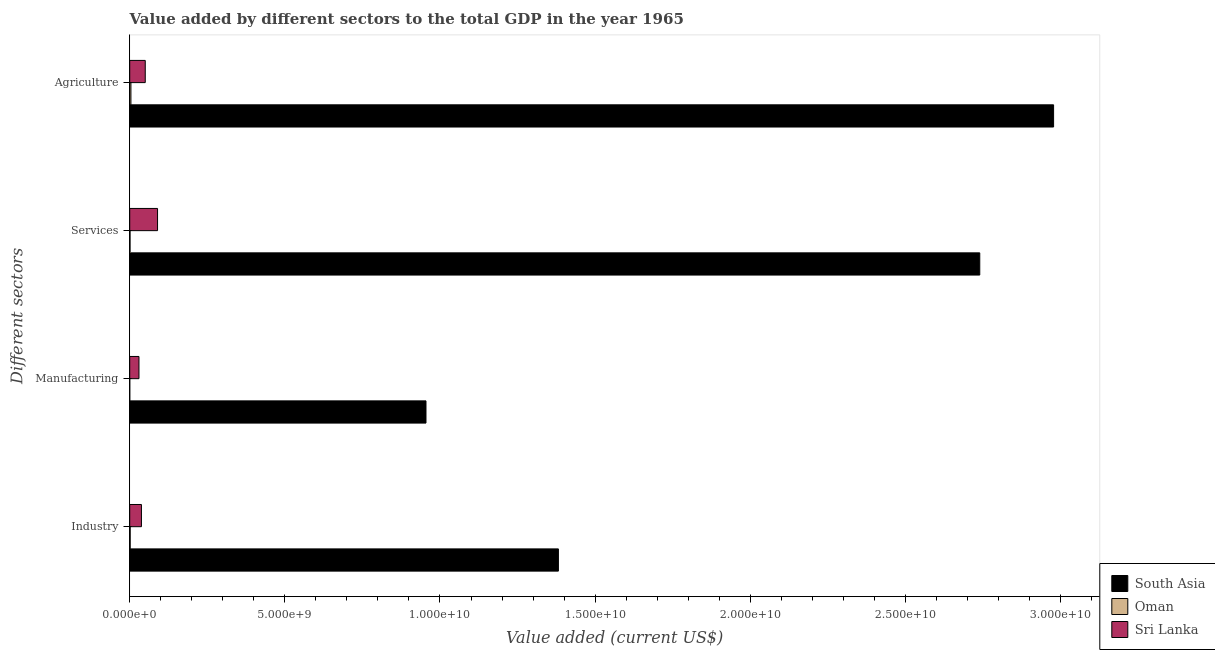How many different coloured bars are there?
Make the answer very short. 3. How many groups of bars are there?
Your answer should be very brief. 4. Are the number of bars per tick equal to the number of legend labels?
Ensure brevity in your answer.  Yes. Are the number of bars on each tick of the Y-axis equal?
Keep it short and to the point. Yes. How many bars are there on the 4th tick from the top?
Provide a succinct answer. 3. How many bars are there on the 2nd tick from the bottom?
Your answer should be compact. 3. What is the label of the 3rd group of bars from the top?
Offer a very short reply. Manufacturing. What is the value added by industrial sector in South Asia?
Provide a succinct answer. 1.38e+1. Across all countries, what is the maximum value added by services sector?
Offer a very short reply. 2.74e+1. Across all countries, what is the minimum value added by industrial sector?
Your answer should be very brief. 1.48e+07. In which country was the value added by agricultural sector minimum?
Your response must be concise. Oman. What is the total value added by industrial sector in the graph?
Ensure brevity in your answer.  1.42e+1. What is the difference between the value added by services sector in Oman and that in Sri Lanka?
Keep it short and to the point. -8.87e+08. What is the difference between the value added by industrial sector in Oman and the value added by services sector in Sri Lanka?
Ensure brevity in your answer.  -8.82e+08. What is the average value added by services sector per country?
Give a very brief answer. 9.44e+09. What is the difference between the value added by agricultural sector and value added by industrial sector in Sri Lanka?
Offer a very short reply. 1.23e+08. In how many countries, is the value added by agricultural sector greater than 17000000000 US$?
Give a very brief answer. 1. What is the ratio of the value added by agricultural sector in Oman to that in Sri Lanka?
Ensure brevity in your answer.  0.08. Is the value added by industrial sector in South Asia less than that in Sri Lanka?
Provide a short and direct response. No. Is the difference between the value added by industrial sector in Oman and Sri Lanka greater than the difference between the value added by services sector in Oman and Sri Lanka?
Give a very brief answer. Yes. What is the difference between the highest and the second highest value added by industrial sector?
Keep it short and to the point. 1.34e+1. What is the difference between the highest and the lowest value added by services sector?
Give a very brief answer. 2.74e+1. Is the sum of the value added by industrial sector in Oman and Sri Lanka greater than the maximum value added by services sector across all countries?
Keep it short and to the point. No. Is it the case that in every country, the sum of the value added by manufacturing sector and value added by industrial sector is greater than the sum of value added by services sector and value added by agricultural sector?
Provide a short and direct response. No. What does the 2nd bar from the top in Agriculture represents?
Give a very brief answer. Oman. Is it the case that in every country, the sum of the value added by industrial sector and value added by manufacturing sector is greater than the value added by services sector?
Give a very brief answer. No. Are all the bars in the graph horizontal?
Offer a terse response. Yes. What is the difference between two consecutive major ticks on the X-axis?
Ensure brevity in your answer.  5.00e+09. What is the title of the graph?
Offer a terse response. Value added by different sectors to the total GDP in the year 1965. What is the label or title of the X-axis?
Your answer should be compact. Value added (current US$). What is the label or title of the Y-axis?
Offer a very short reply. Different sectors. What is the Value added (current US$) of South Asia in Industry?
Your answer should be compact. 1.38e+1. What is the Value added (current US$) of Oman in Industry?
Your response must be concise. 1.48e+07. What is the Value added (current US$) in Sri Lanka in Industry?
Keep it short and to the point. 3.78e+08. What is the Value added (current US$) of South Asia in Manufacturing?
Provide a short and direct response. 9.55e+09. What is the Value added (current US$) in Oman in Manufacturing?
Provide a succinct answer. 2.80e+05. What is the Value added (current US$) of Sri Lanka in Manufacturing?
Make the answer very short. 2.98e+08. What is the Value added (current US$) in South Asia in Services?
Offer a very short reply. 2.74e+1. What is the Value added (current US$) in Oman in Services?
Provide a short and direct response. 1.01e+07. What is the Value added (current US$) of Sri Lanka in Services?
Your response must be concise. 8.97e+08. What is the Value added (current US$) in South Asia in Agriculture?
Your answer should be very brief. 2.98e+1. What is the Value added (current US$) in Oman in Agriculture?
Ensure brevity in your answer.  3.84e+07. What is the Value added (current US$) in Sri Lanka in Agriculture?
Ensure brevity in your answer.  5.01e+08. Across all Different sectors, what is the maximum Value added (current US$) in South Asia?
Make the answer very short. 2.98e+1. Across all Different sectors, what is the maximum Value added (current US$) of Oman?
Keep it short and to the point. 3.84e+07. Across all Different sectors, what is the maximum Value added (current US$) in Sri Lanka?
Provide a short and direct response. 8.97e+08. Across all Different sectors, what is the minimum Value added (current US$) of South Asia?
Ensure brevity in your answer.  9.55e+09. Across all Different sectors, what is the minimum Value added (current US$) in Oman?
Offer a very short reply. 2.80e+05. Across all Different sectors, what is the minimum Value added (current US$) of Sri Lanka?
Make the answer very short. 2.98e+08. What is the total Value added (current US$) in South Asia in the graph?
Provide a succinct answer. 8.05e+1. What is the total Value added (current US$) in Oman in the graph?
Make the answer very short. 6.36e+07. What is the total Value added (current US$) in Sri Lanka in the graph?
Offer a terse response. 2.07e+09. What is the difference between the Value added (current US$) in South Asia in Industry and that in Manufacturing?
Offer a terse response. 4.27e+09. What is the difference between the Value added (current US$) of Oman in Industry and that in Manufacturing?
Offer a terse response. 1.46e+07. What is the difference between the Value added (current US$) of Sri Lanka in Industry and that in Manufacturing?
Keep it short and to the point. 8.00e+07. What is the difference between the Value added (current US$) in South Asia in Industry and that in Services?
Your answer should be compact. -1.36e+1. What is the difference between the Value added (current US$) in Oman in Industry and that in Services?
Offer a terse response. 4.76e+06. What is the difference between the Value added (current US$) of Sri Lanka in Industry and that in Services?
Your answer should be compact. -5.19e+08. What is the difference between the Value added (current US$) in South Asia in Industry and that in Agriculture?
Give a very brief answer. -1.60e+1. What is the difference between the Value added (current US$) of Oman in Industry and that in Agriculture?
Your answer should be compact. -2.35e+07. What is the difference between the Value added (current US$) of Sri Lanka in Industry and that in Agriculture?
Keep it short and to the point. -1.23e+08. What is the difference between the Value added (current US$) of South Asia in Manufacturing and that in Services?
Provide a short and direct response. -1.78e+1. What is the difference between the Value added (current US$) of Oman in Manufacturing and that in Services?
Your response must be concise. -9.80e+06. What is the difference between the Value added (current US$) of Sri Lanka in Manufacturing and that in Services?
Your answer should be very brief. -5.99e+08. What is the difference between the Value added (current US$) in South Asia in Manufacturing and that in Agriculture?
Provide a short and direct response. -2.02e+1. What is the difference between the Value added (current US$) of Oman in Manufacturing and that in Agriculture?
Ensure brevity in your answer.  -3.81e+07. What is the difference between the Value added (current US$) in Sri Lanka in Manufacturing and that in Agriculture?
Provide a succinct answer. -2.03e+08. What is the difference between the Value added (current US$) in South Asia in Services and that in Agriculture?
Offer a terse response. -2.38e+09. What is the difference between the Value added (current US$) of Oman in Services and that in Agriculture?
Your response must be concise. -2.83e+07. What is the difference between the Value added (current US$) of Sri Lanka in Services and that in Agriculture?
Ensure brevity in your answer.  3.96e+08. What is the difference between the Value added (current US$) in South Asia in Industry and the Value added (current US$) in Oman in Manufacturing?
Give a very brief answer. 1.38e+1. What is the difference between the Value added (current US$) of South Asia in Industry and the Value added (current US$) of Sri Lanka in Manufacturing?
Your answer should be compact. 1.35e+1. What is the difference between the Value added (current US$) in Oman in Industry and the Value added (current US$) in Sri Lanka in Manufacturing?
Give a very brief answer. -2.83e+08. What is the difference between the Value added (current US$) of South Asia in Industry and the Value added (current US$) of Oman in Services?
Provide a short and direct response. 1.38e+1. What is the difference between the Value added (current US$) in South Asia in Industry and the Value added (current US$) in Sri Lanka in Services?
Your response must be concise. 1.29e+1. What is the difference between the Value added (current US$) of Oman in Industry and the Value added (current US$) of Sri Lanka in Services?
Provide a short and direct response. -8.82e+08. What is the difference between the Value added (current US$) in South Asia in Industry and the Value added (current US$) in Oman in Agriculture?
Make the answer very short. 1.38e+1. What is the difference between the Value added (current US$) in South Asia in Industry and the Value added (current US$) in Sri Lanka in Agriculture?
Provide a succinct answer. 1.33e+1. What is the difference between the Value added (current US$) in Oman in Industry and the Value added (current US$) in Sri Lanka in Agriculture?
Give a very brief answer. -4.86e+08. What is the difference between the Value added (current US$) in South Asia in Manufacturing and the Value added (current US$) in Oman in Services?
Give a very brief answer. 9.54e+09. What is the difference between the Value added (current US$) of South Asia in Manufacturing and the Value added (current US$) of Sri Lanka in Services?
Ensure brevity in your answer.  8.65e+09. What is the difference between the Value added (current US$) of Oman in Manufacturing and the Value added (current US$) of Sri Lanka in Services?
Your answer should be very brief. -8.96e+08. What is the difference between the Value added (current US$) in South Asia in Manufacturing and the Value added (current US$) in Oman in Agriculture?
Your answer should be compact. 9.51e+09. What is the difference between the Value added (current US$) of South Asia in Manufacturing and the Value added (current US$) of Sri Lanka in Agriculture?
Give a very brief answer. 9.05e+09. What is the difference between the Value added (current US$) in Oman in Manufacturing and the Value added (current US$) in Sri Lanka in Agriculture?
Offer a terse response. -5.00e+08. What is the difference between the Value added (current US$) of South Asia in Services and the Value added (current US$) of Oman in Agriculture?
Give a very brief answer. 2.74e+1. What is the difference between the Value added (current US$) of South Asia in Services and the Value added (current US$) of Sri Lanka in Agriculture?
Your response must be concise. 2.69e+1. What is the difference between the Value added (current US$) in Oman in Services and the Value added (current US$) in Sri Lanka in Agriculture?
Make the answer very short. -4.91e+08. What is the average Value added (current US$) of South Asia per Different sectors?
Provide a succinct answer. 2.01e+1. What is the average Value added (current US$) of Oman per Different sectors?
Keep it short and to the point. 1.59e+07. What is the average Value added (current US$) in Sri Lanka per Different sectors?
Provide a succinct answer. 5.18e+08. What is the difference between the Value added (current US$) of South Asia and Value added (current US$) of Oman in Industry?
Offer a very short reply. 1.38e+1. What is the difference between the Value added (current US$) in South Asia and Value added (current US$) in Sri Lanka in Industry?
Your answer should be compact. 1.34e+1. What is the difference between the Value added (current US$) of Oman and Value added (current US$) of Sri Lanka in Industry?
Provide a succinct answer. -3.63e+08. What is the difference between the Value added (current US$) in South Asia and Value added (current US$) in Oman in Manufacturing?
Ensure brevity in your answer.  9.55e+09. What is the difference between the Value added (current US$) in South Asia and Value added (current US$) in Sri Lanka in Manufacturing?
Your answer should be very brief. 9.25e+09. What is the difference between the Value added (current US$) in Oman and Value added (current US$) in Sri Lanka in Manufacturing?
Give a very brief answer. -2.97e+08. What is the difference between the Value added (current US$) of South Asia and Value added (current US$) of Oman in Services?
Make the answer very short. 2.74e+1. What is the difference between the Value added (current US$) of South Asia and Value added (current US$) of Sri Lanka in Services?
Give a very brief answer. 2.65e+1. What is the difference between the Value added (current US$) in Oman and Value added (current US$) in Sri Lanka in Services?
Your answer should be compact. -8.87e+08. What is the difference between the Value added (current US$) of South Asia and Value added (current US$) of Oman in Agriculture?
Your answer should be very brief. 2.97e+1. What is the difference between the Value added (current US$) of South Asia and Value added (current US$) of Sri Lanka in Agriculture?
Offer a terse response. 2.93e+1. What is the difference between the Value added (current US$) of Oman and Value added (current US$) of Sri Lanka in Agriculture?
Your response must be concise. -4.62e+08. What is the ratio of the Value added (current US$) of South Asia in Industry to that in Manufacturing?
Make the answer very short. 1.45. What is the ratio of the Value added (current US$) of Sri Lanka in Industry to that in Manufacturing?
Offer a very short reply. 1.27. What is the ratio of the Value added (current US$) in South Asia in Industry to that in Services?
Provide a succinct answer. 0.5. What is the ratio of the Value added (current US$) in Oman in Industry to that in Services?
Offer a terse response. 1.47. What is the ratio of the Value added (current US$) in Sri Lanka in Industry to that in Services?
Ensure brevity in your answer.  0.42. What is the ratio of the Value added (current US$) of South Asia in Industry to that in Agriculture?
Your answer should be compact. 0.46. What is the ratio of the Value added (current US$) in Oman in Industry to that in Agriculture?
Provide a succinct answer. 0.39. What is the ratio of the Value added (current US$) in Sri Lanka in Industry to that in Agriculture?
Offer a terse response. 0.75. What is the ratio of the Value added (current US$) of South Asia in Manufacturing to that in Services?
Your answer should be very brief. 0.35. What is the ratio of the Value added (current US$) in Oman in Manufacturing to that in Services?
Your answer should be compact. 0.03. What is the ratio of the Value added (current US$) of Sri Lanka in Manufacturing to that in Services?
Offer a terse response. 0.33. What is the ratio of the Value added (current US$) in South Asia in Manufacturing to that in Agriculture?
Your response must be concise. 0.32. What is the ratio of the Value added (current US$) in Oman in Manufacturing to that in Agriculture?
Provide a short and direct response. 0.01. What is the ratio of the Value added (current US$) of Sri Lanka in Manufacturing to that in Agriculture?
Offer a terse response. 0.59. What is the ratio of the Value added (current US$) in South Asia in Services to that in Agriculture?
Your answer should be very brief. 0.92. What is the ratio of the Value added (current US$) in Oman in Services to that in Agriculture?
Your answer should be very brief. 0.26. What is the ratio of the Value added (current US$) of Sri Lanka in Services to that in Agriculture?
Your answer should be very brief. 1.79. What is the difference between the highest and the second highest Value added (current US$) in South Asia?
Your response must be concise. 2.38e+09. What is the difference between the highest and the second highest Value added (current US$) in Oman?
Your response must be concise. 2.35e+07. What is the difference between the highest and the second highest Value added (current US$) in Sri Lanka?
Make the answer very short. 3.96e+08. What is the difference between the highest and the lowest Value added (current US$) of South Asia?
Your answer should be compact. 2.02e+1. What is the difference between the highest and the lowest Value added (current US$) of Oman?
Your answer should be compact. 3.81e+07. What is the difference between the highest and the lowest Value added (current US$) of Sri Lanka?
Provide a succinct answer. 5.99e+08. 